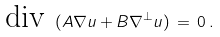<formula> <loc_0><loc_0><loc_500><loc_500>\text {div } ( A \nabla u + B \nabla ^ { \perp } u ) \, = \, 0 \, .</formula> 